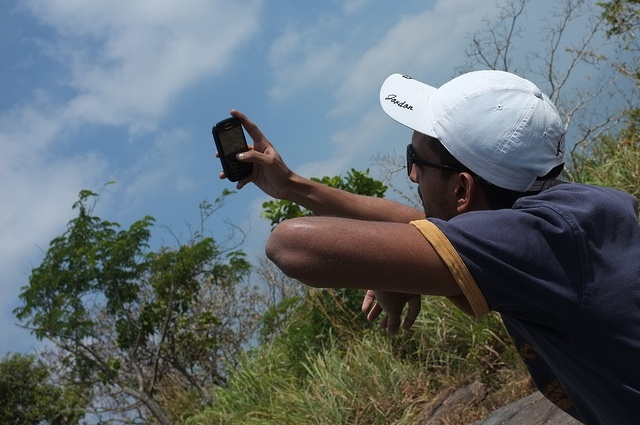Describe the objects in this image and their specific colors. I can see people in gray, black, and lightgray tones and cell phone in gray, black, darkblue, and blue tones in this image. 